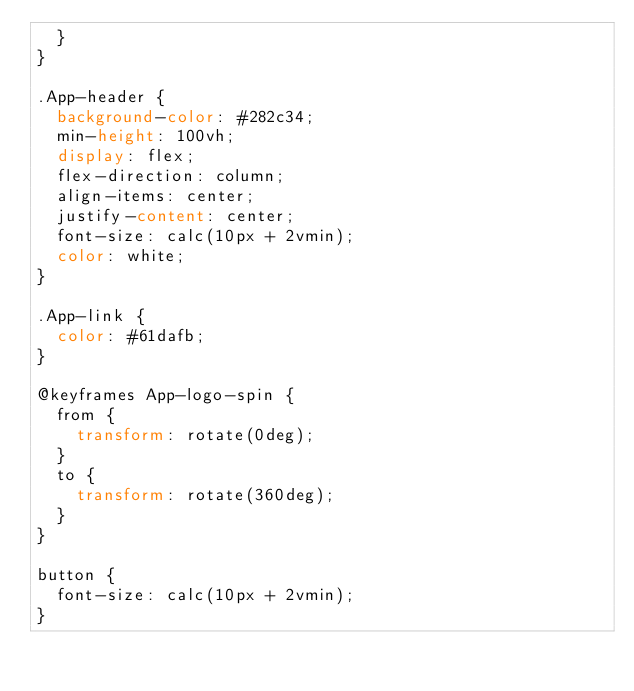<code> <loc_0><loc_0><loc_500><loc_500><_CSS_>  }
}

.App-header {
  background-color: #282c34;
  min-height: 100vh;
  display: flex;
  flex-direction: column;
  align-items: center;
  justify-content: center;
  font-size: calc(10px + 2vmin);
  color: white;
}

.App-link {
  color: #61dafb;
}

@keyframes App-logo-spin {
  from {
    transform: rotate(0deg);
  }
  to {
    transform: rotate(360deg);
  }
}

button {
  font-size: calc(10px + 2vmin);
}
</code> 